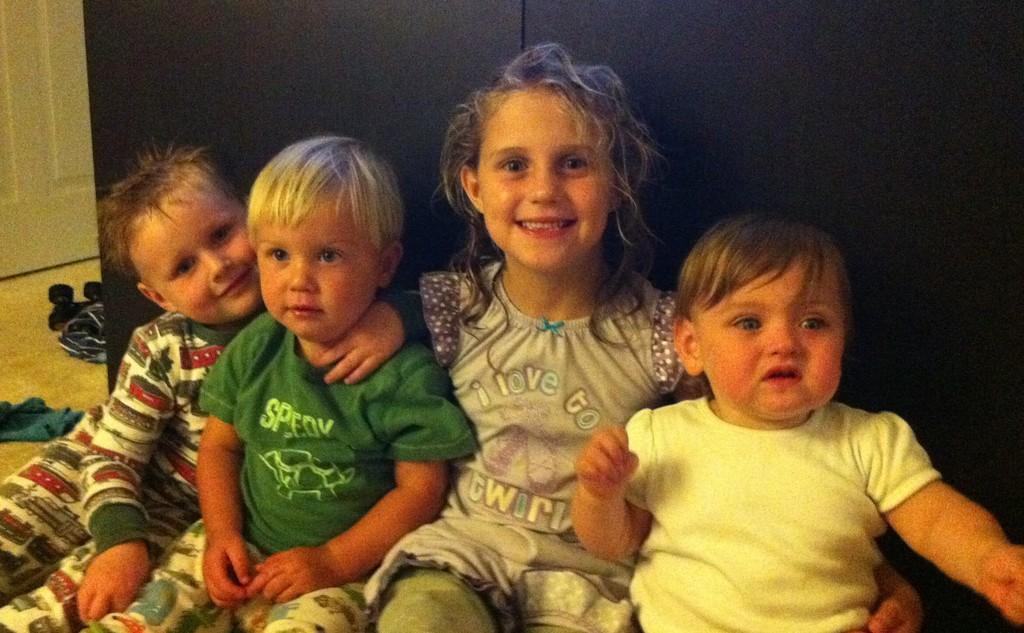Could you give a brief overview of what you see in this image? In this picture I can observe four children sitting on the floor. Three of them are smiling. On the left side there are some clothes placed on the floor. I can observe a door on the left side. Behind them there is a black color wall. 